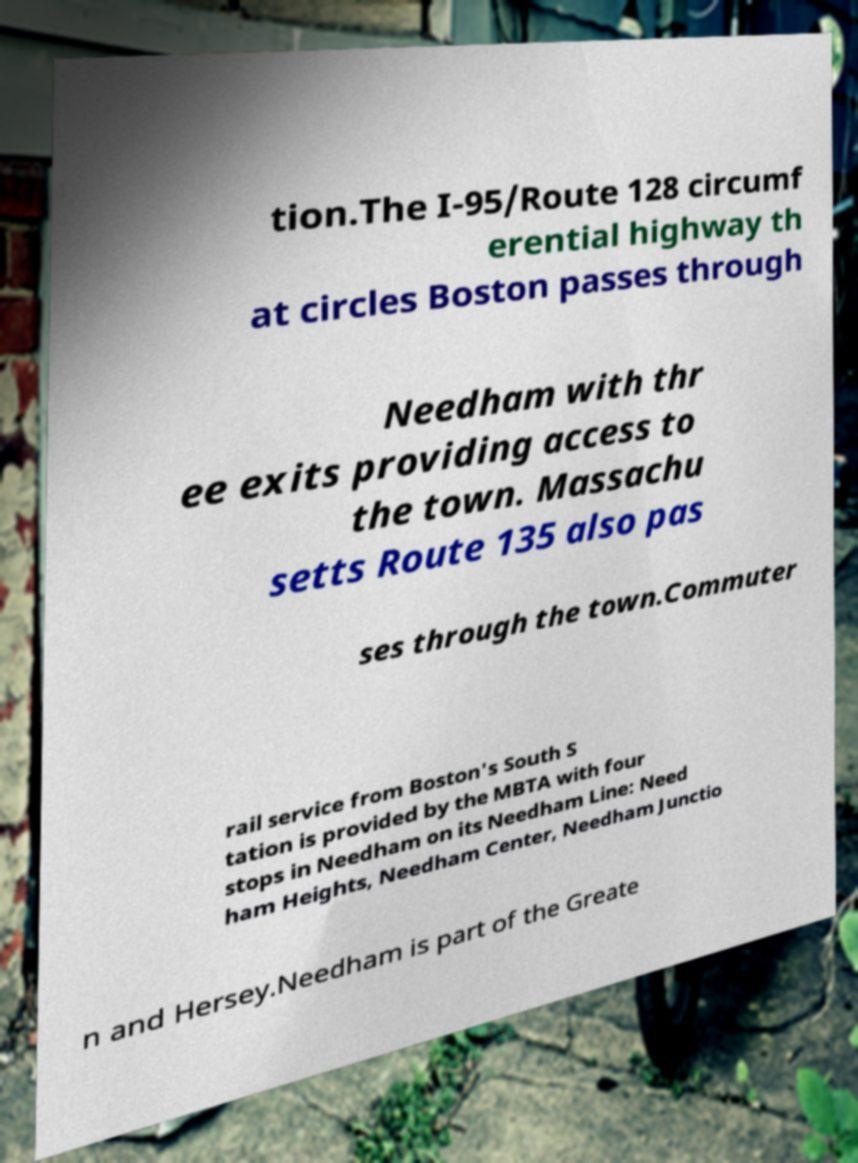What messages or text are displayed in this image? I need them in a readable, typed format. tion.The I-95/Route 128 circumf erential highway th at circles Boston passes through Needham with thr ee exits providing access to the town. Massachu setts Route 135 also pas ses through the town.Commuter rail service from Boston's South S tation is provided by the MBTA with four stops in Needham on its Needham Line: Need ham Heights, Needham Center, Needham Junctio n and Hersey.Needham is part of the Greate 